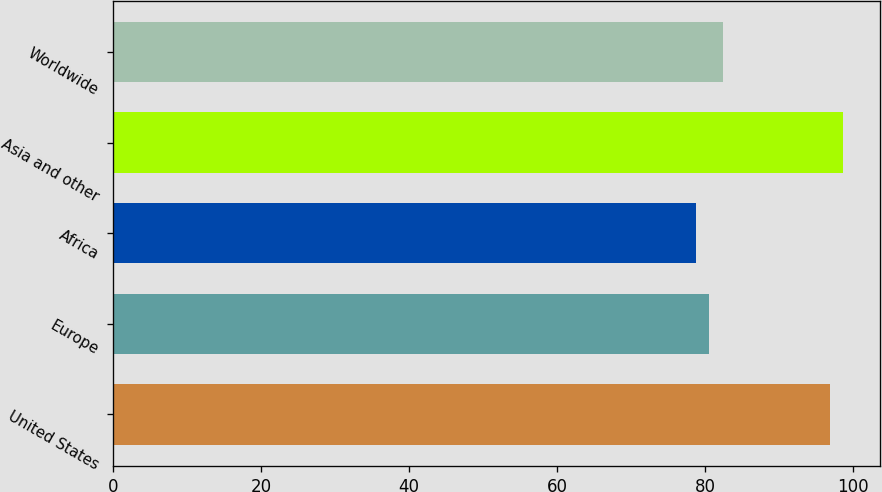<chart> <loc_0><loc_0><loc_500><loc_500><bar_chart><fcel>United States<fcel>Europe<fcel>Africa<fcel>Asia and other<fcel>Worldwide<nl><fcel>96.82<fcel>80.55<fcel>78.72<fcel>98.65<fcel>82.38<nl></chart> 